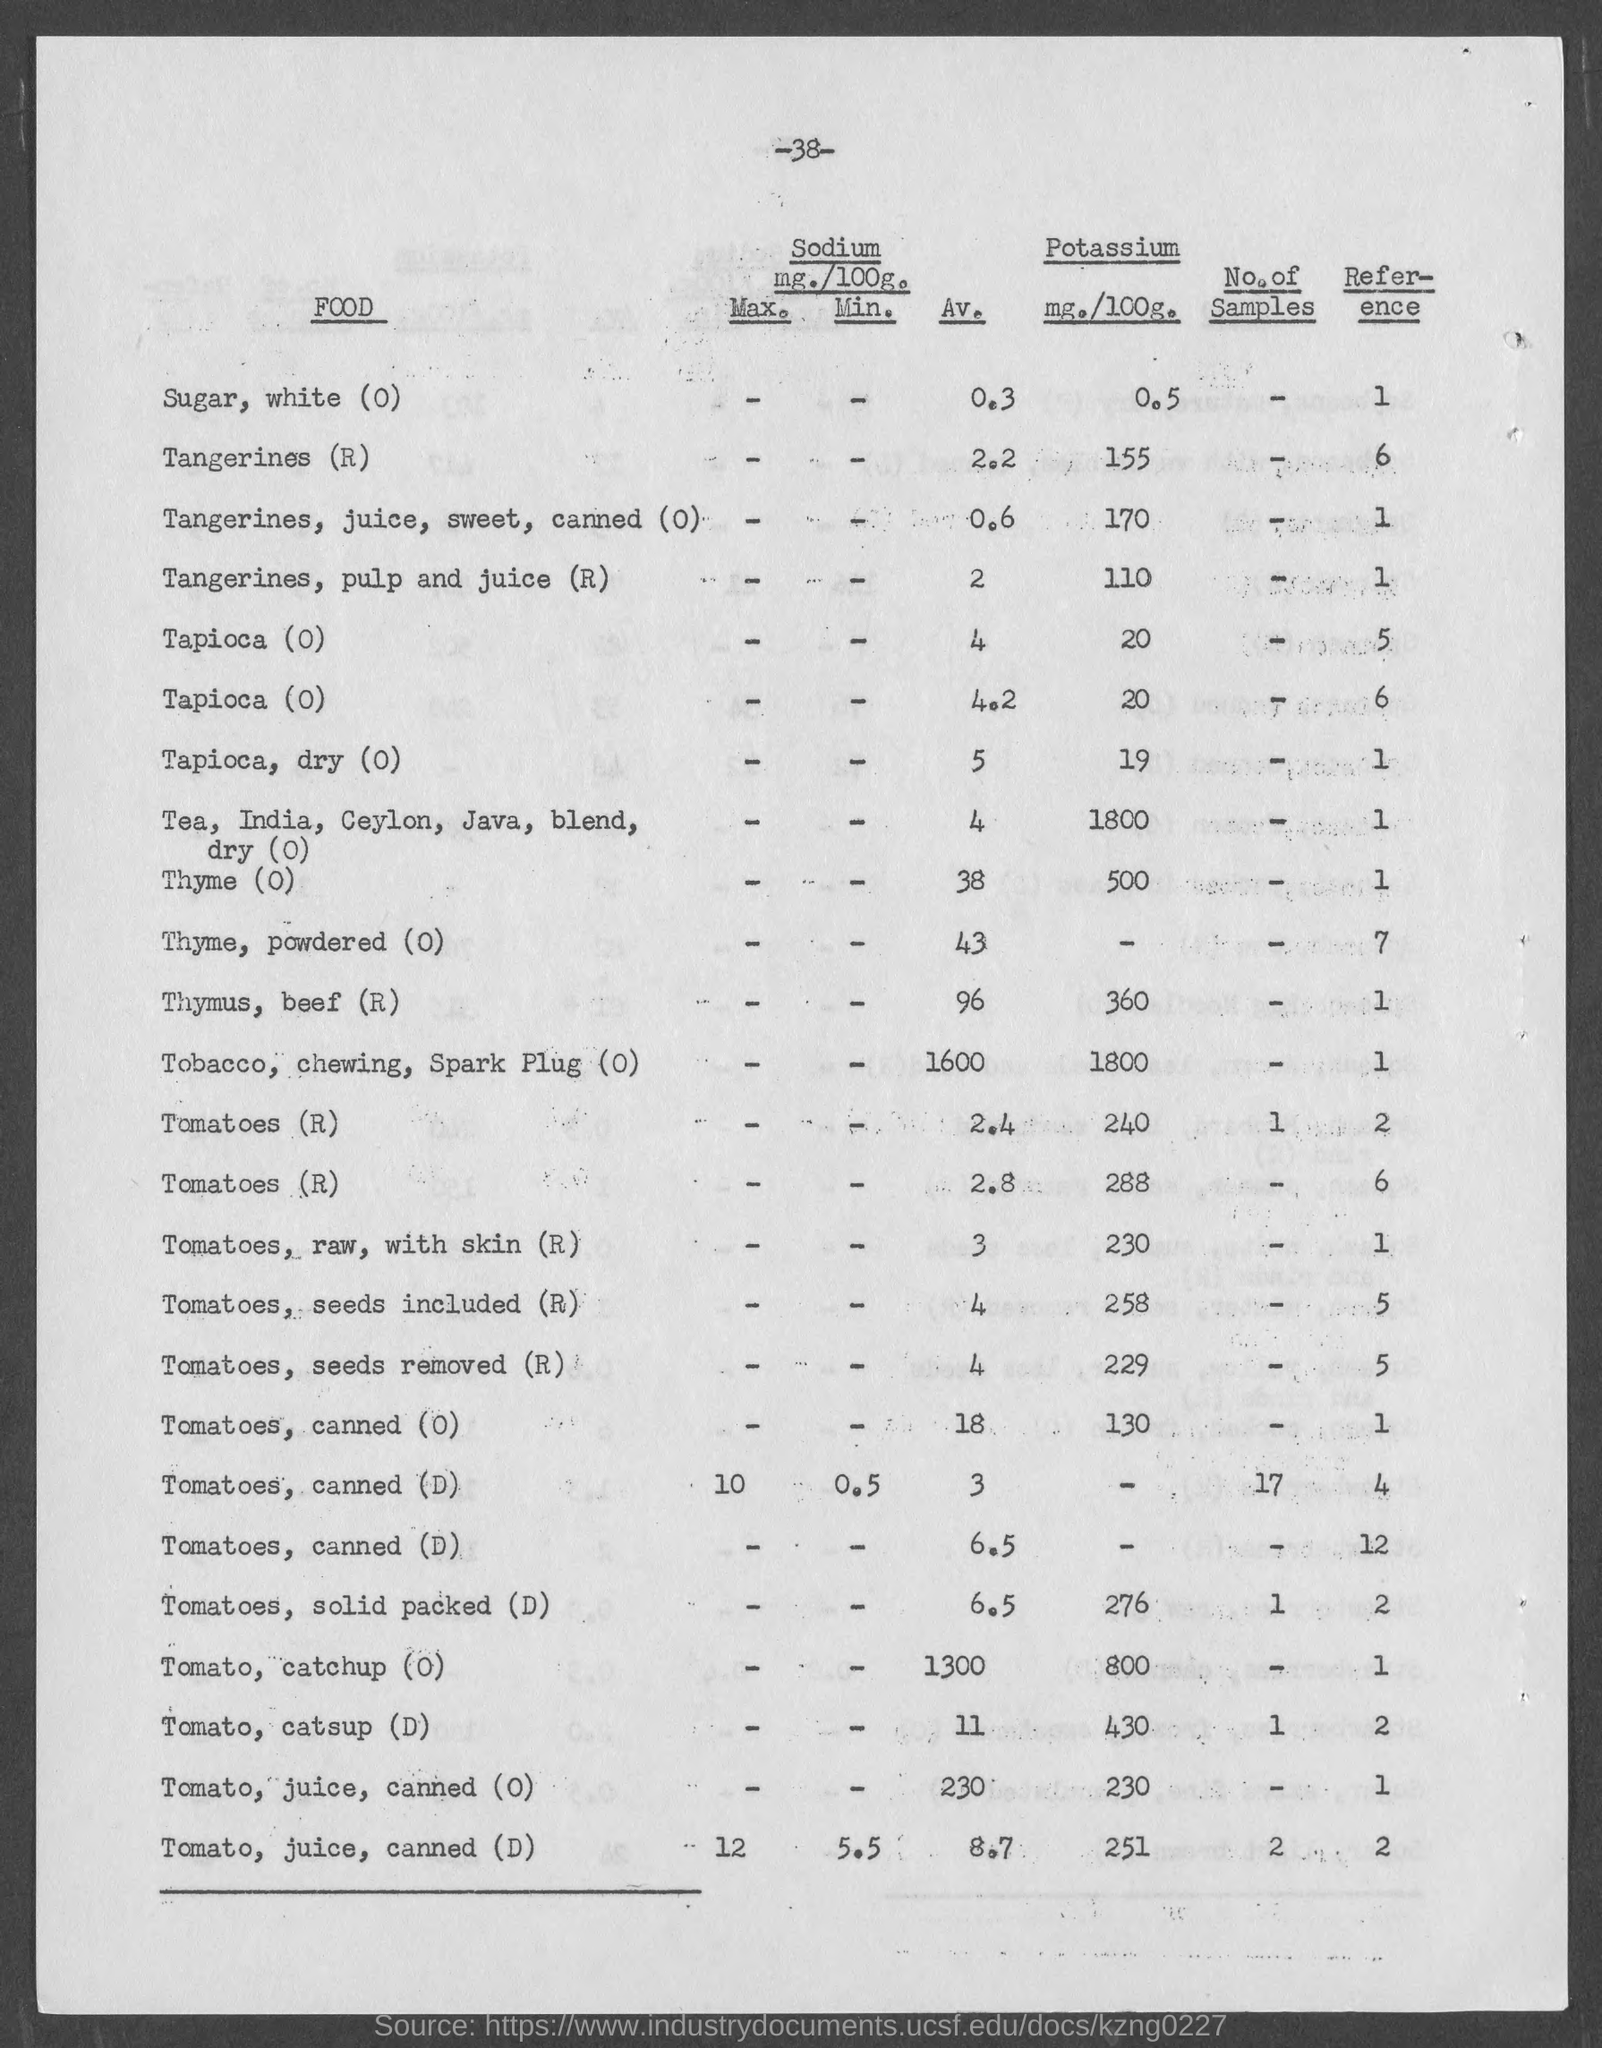What is the page no mentioned in this document?
Give a very brief answer. 38. What is the reference given for Sugar, white (0)?
Make the answer very short. 1. What is the Average amount of sodium (mg./100g.) present in Tangerines (R)?
Your response must be concise. 2.2. What is the average amount of sodium (mg./100g.) present in Thyme (0)?
Offer a terse response. 38. What is the amount of Pottasium (mg./100g.) present in Tapioca (0)?
Give a very brief answer. 20. What is the reference given for Thyme, powdered (0)?
Give a very brief answer. 7. What is the amount of Pottasium (mg./100g.) present in Tomatoes, canned (0)?
Offer a terse response. 130. 